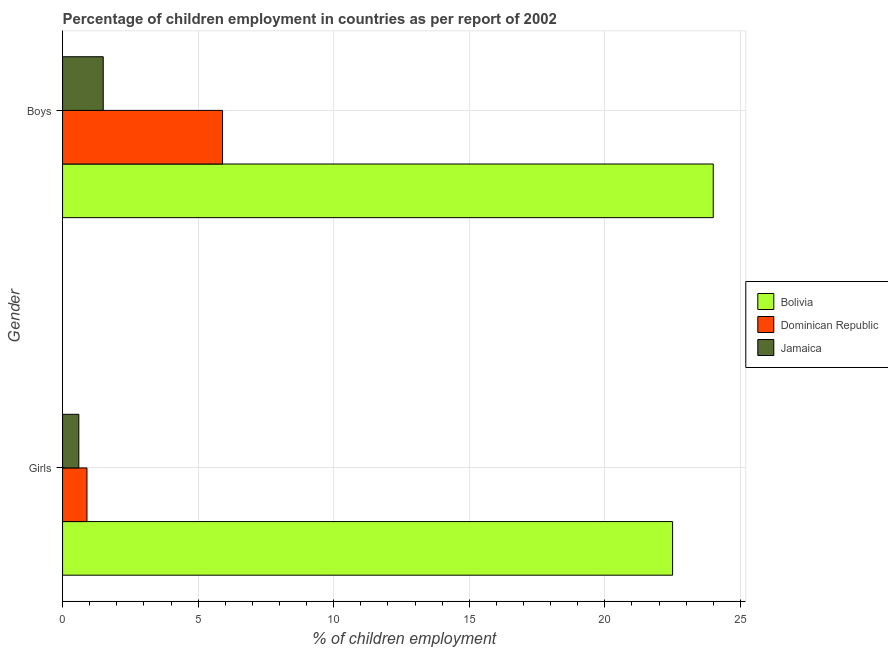How many bars are there on the 1st tick from the top?
Make the answer very short. 3. How many bars are there on the 1st tick from the bottom?
Your answer should be compact. 3. What is the label of the 2nd group of bars from the top?
Provide a short and direct response. Girls. What is the percentage of employed girls in Bolivia?
Make the answer very short. 22.5. Across all countries, what is the maximum percentage of employed boys?
Your answer should be compact. 24. Across all countries, what is the minimum percentage of employed boys?
Offer a terse response. 1.5. In which country was the percentage of employed girls maximum?
Your answer should be very brief. Bolivia. In which country was the percentage of employed boys minimum?
Offer a terse response. Jamaica. What is the total percentage of employed boys in the graph?
Your response must be concise. 31.4. What is the difference between the percentage of employed boys in Jamaica and that in Bolivia?
Offer a very short reply. -22.5. What is the average percentage of employed boys per country?
Offer a very short reply. 10.47. What is the difference between the percentage of employed boys and percentage of employed girls in Bolivia?
Make the answer very short. 1.5. What is the ratio of the percentage of employed girls in Jamaica to that in Dominican Republic?
Give a very brief answer. 0.67. Is the percentage of employed boys in Bolivia less than that in Jamaica?
Ensure brevity in your answer.  No. In how many countries, is the percentage of employed boys greater than the average percentage of employed boys taken over all countries?
Your answer should be very brief. 1. What does the 1st bar from the top in Girls represents?
Offer a terse response. Jamaica. What does the 1st bar from the bottom in Boys represents?
Provide a short and direct response. Bolivia. Does the graph contain any zero values?
Ensure brevity in your answer.  No. Does the graph contain grids?
Keep it short and to the point. Yes. Where does the legend appear in the graph?
Ensure brevity in your answer.  Center right. How many legend labels are there?
Your response must be concise. 3. How are the legend labels stacked?
Give a very brief answer. Vertical. What is the title of the graph?
Make the answer very short. Percentage of children employment in countries as per report of 2002. What is the label or title of the X-axis?
Provide a short and direct response. % of children employment. What is the % of children employment of Dominican Republic in Girls?
Your answer should be very brief. 0.9. What is the % of children employment of Jamaica in Boys?
Keep it short and to the point. 1.5. Across all Gender, what is the maximum % of children employment of Bolivia?
Your answer should be compact. 24. Across all Gender, what is the maximum % of children employment of Dominican Republic?
Provide a succinct answer. 5.9. Across all Gender, what is the minimum % of children employment of Bolivia?
Your answer should be very brief. 22.5. Across all Gender, what is the minimum % of children employment in Dominican Republic?
Provide a short and direct response. 0.9. What is the total % of children employment of Bolivia in the graph?
Ensure brevity in your answer.  46.5. What is the total % of children employment of Jamaica in the graph?
Your answer should be very brief. 2.1. What is the difference between the % of children employment of Bolivia in Girls and that in Boys?
Ensure brevity in your answer.  -1.5. What is the difference between the % of children employment in Dominican Republic in Girls and that in Boys?
Offer a terse response. -5. What is the difference between the % of children employment of Jamaica in Girls and that in Boys?
Provide a short and direct response. -0.9. What is the difference between the % of children employment in Bolivia in Girls and the % of children employment in Dominican Republic in Boys?
Your answer should be compact. 16.6. What is the difference between the % of children employment in Dominican Republic in Girls and the % of children employment in Jamaica in Boys?
Provide a short and direct response. -0.6. What is the average % of children employment of Bolivia per Gender?
Ensure brevity in your answer.  23.25. What is the difference between the % of children employment of Bolivia and % of children employment of Dominican Republic in Girls?
Your response must be concise. 21.6. What is the difference between the % of children employment in Bolivia and % of children employment in Jamaica in Girls?
Ensure brevity in your answer.  21.9. What is the difference between the % of children employment in Dominican Republic and % of children employment in Jamaica in Girls?
Offer a very short reply. 0.3. What is the difference between the % of children employment of Bolivia and % of children employment of Dominican Republic in Boys?
Ensure brevity in your answer.  18.1. What is the ratio of the % of children employment of Bolivia in Girls to that in Boys?
Keep it short and to the point. 0.94. What is the ratio of the % of children employment in Dominican Republic in Girls to that in Boys?
Keep it short and to the point. 0.15. What is the ratio of the % of children employment in Jamaica in Girls to that in Boys?
Your answer should be compact. 0.4. What is the difference between the highest and the second highest % of children employment in Bolivia?
Make the answer very short. 1.5. What is the difference between the highest and the second highest % of children employment of Jamaica?
Offer a terse response. 0.9. What is the difference between the highest and the lowest % of children employment in Dominican Republic?
Ensure brevity in your answer.  5. 